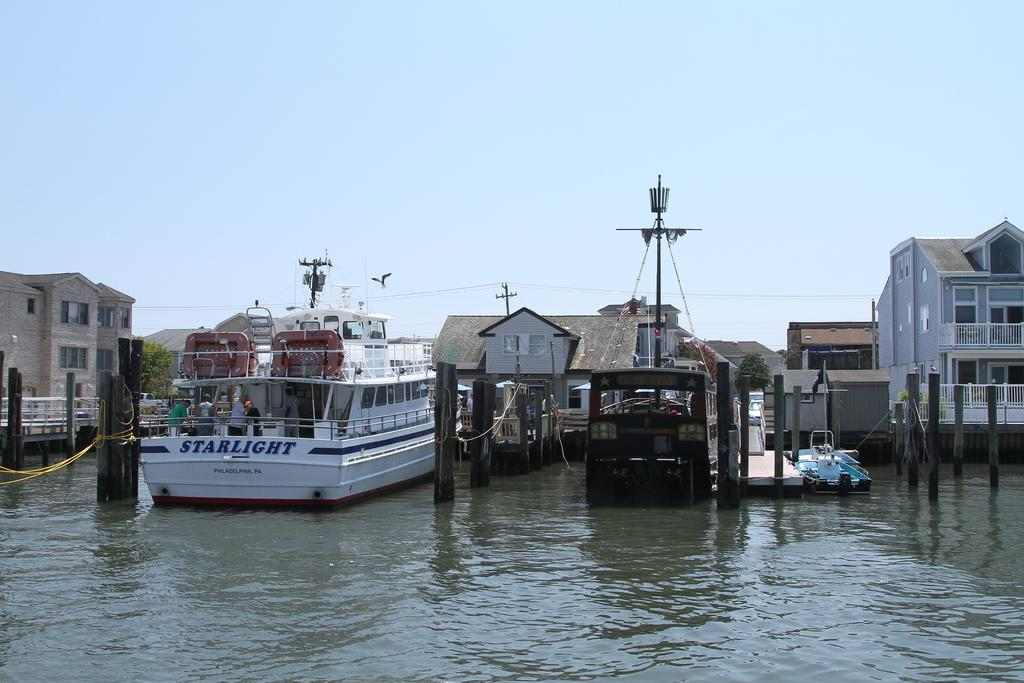What is located in the center of the image? There are buildings in the center of the image. What is at the bottom of the image? There is water at the bottom of the image. What can be seen floating on the water? A boat is visible on the water. What is visible in the background of the image? There is sky in the background of the image. Can you tell me how many receipts are floating on the water in the image? There are no receipts present in the image; it features a boat on the water. What type of structure is shown smashing into the buildings in the image? There is no structure shown smashing into the buildings in the image; it only shows buildings, water, a boat, and sky. 